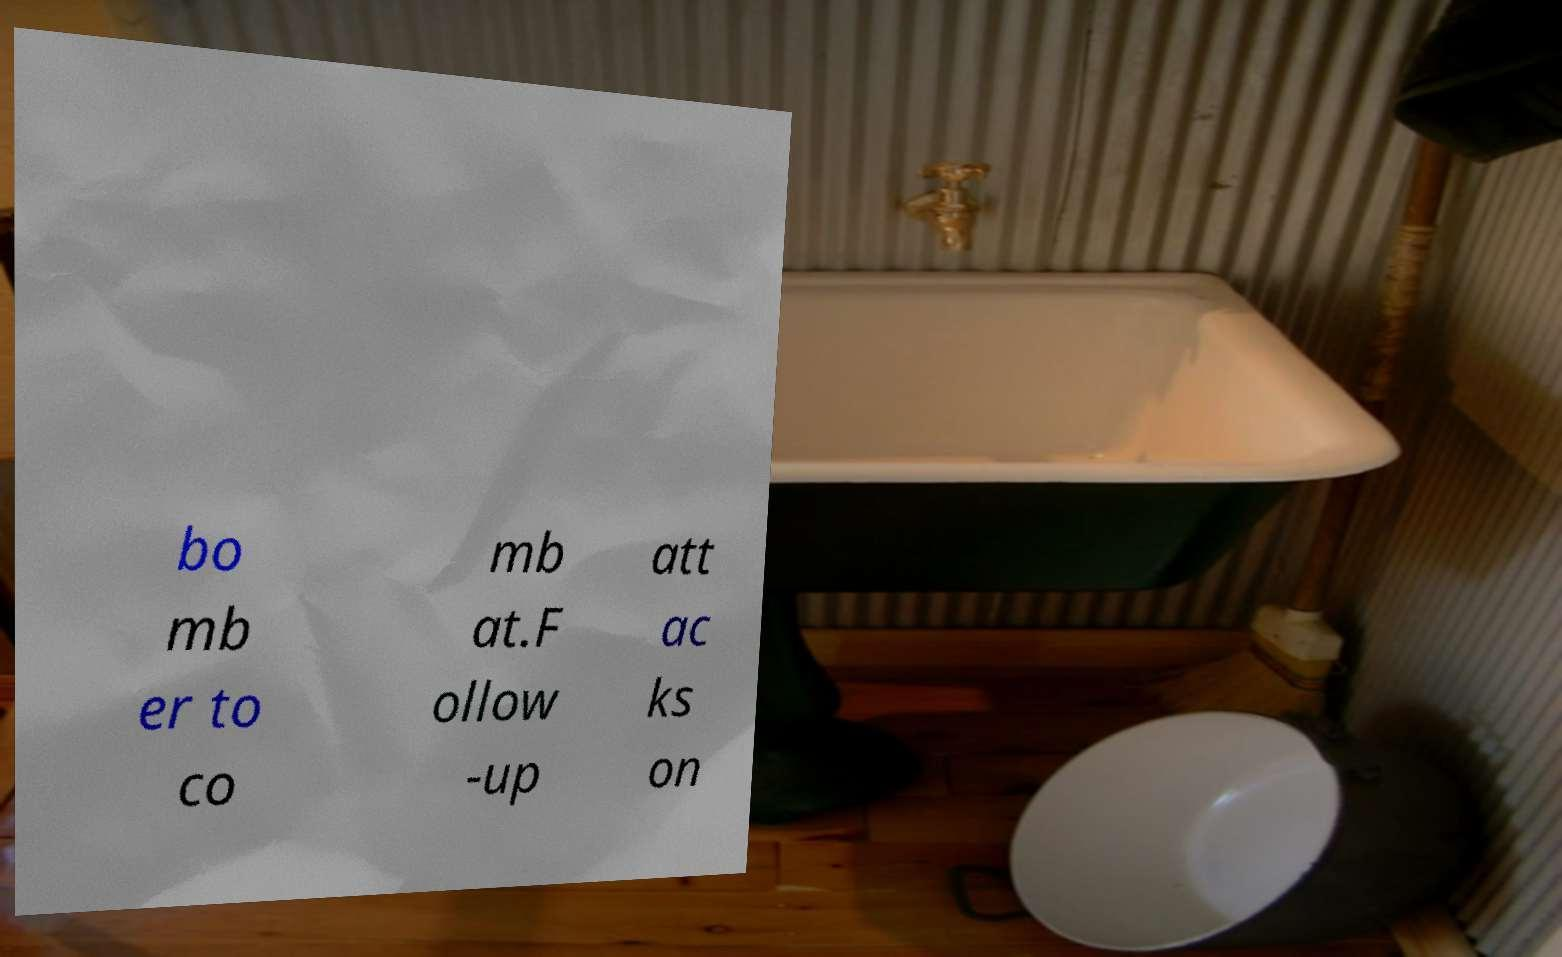Please read and relay the text visible in this image. What does it say? bo mb er to co mb at.F ollow -up att ac ks on 